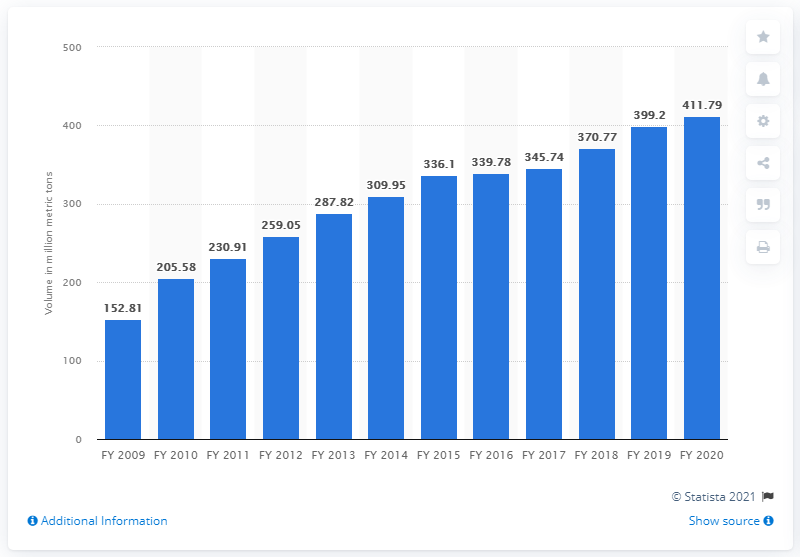Draw attention to some important aspects in this diagram. At the end of the financial year of 2020, Gujarat's total cargo traffic was 411.79. 